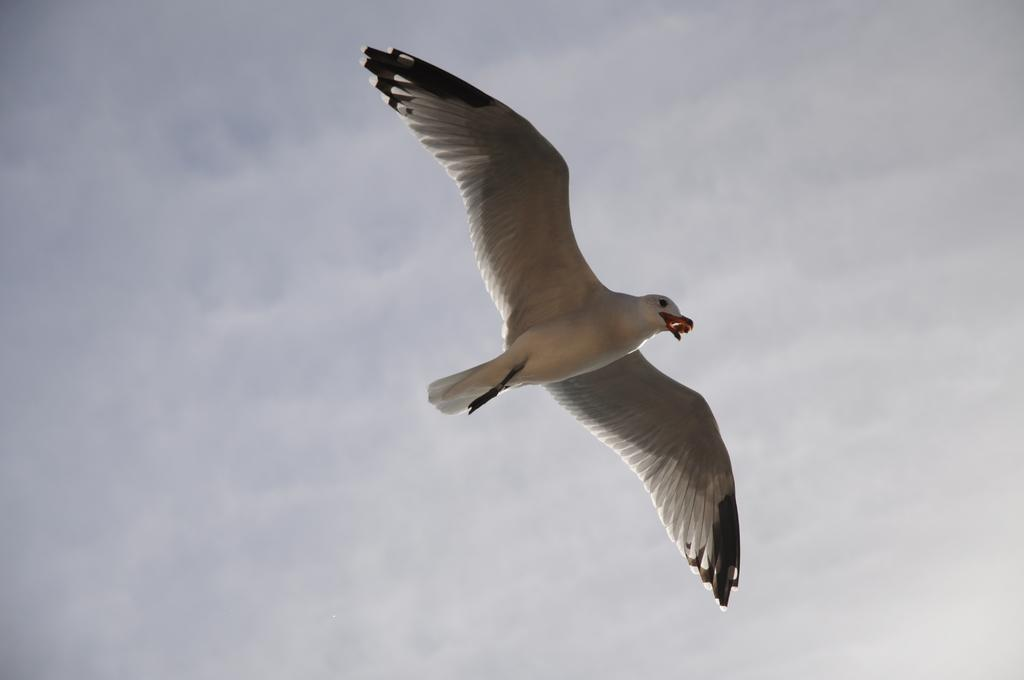What is the main subject of the image? There is a bird flying in the air in the image. What can be seen in the background of the image? The sky is visible in the image. What is the condition of the sky in the image? Clouds are present in the sky. How does the bird use its breath to control the fire in the image? There is no fire present in the image, and birds do not have the ability to control fire with their breath. 